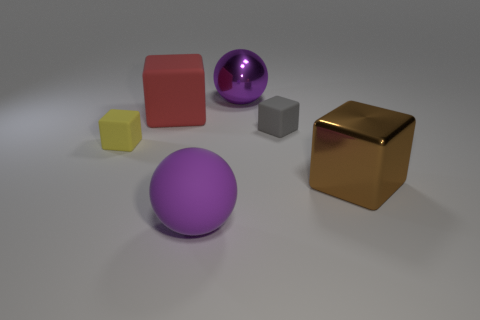Does the large metal thing behind the big brown metal block have the same color as the large sphere in front of the large brown metallic cube?
Your response must be concise. Yes. There is a thing that is the same size as the yellow matte block; what material is it?
Your answer should be compact. Rubber. There is a purple thing right of the purple rubber thing to the right of the tiny matte block in front of the tiny gray rubber cube; what is its shape?
Your response must be concise. Sphere. The red rubber object that is the same size as the brown thing is what shape?
Provide a succinct answer. Cube. How many purple objects are on the left side of the big purple thing that is behind the brown shiny block in front of the big red cube?
Give a very brief answer. 1. Are there more spheres in front of the brown metallic thing than tiny yellow blocks that are behind the tiny gray matte thing?
Offer a terse response. Yes. What number of other objects are the same shape as the purple matte thing?
Provide a short and direct response. 1. What number of objects are either purple balls that are left of the purple shiny sphere or large things in front of the red matte object?
Ensure brevity in your answer.  2. There is a big purple thing that is behind the purple object in front of the small matte cube that is behind the yellow thing; what is its material?
Give a very brief answer. Metal. Does the big rubber thing that is in front of the large red thing have the same color as the big metal ball?
Ensure brevity in your answer.  Yes. 